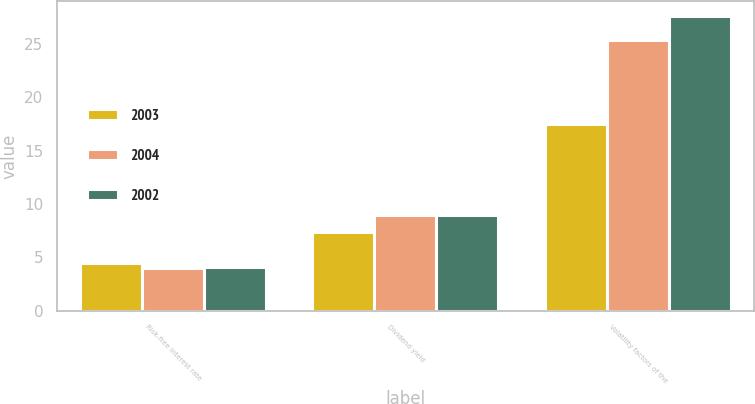<chart> <loc_0><loc_0><loc_500><loc_500><stacked_bar_chart><ecel><fcel>Risk-free interest rate<fcel>Dividend yield<fcel>Volatility factors of the<nl><fcel>2003<fcel>4.5<fcel>7.4<fcel>17.5<nl><fcel>2004<fcel>4<fcel>9<fcel>25.4<nl><fcel>2002<fcel>4.1<fcel>9<fcel>27.6<nl></chart> 